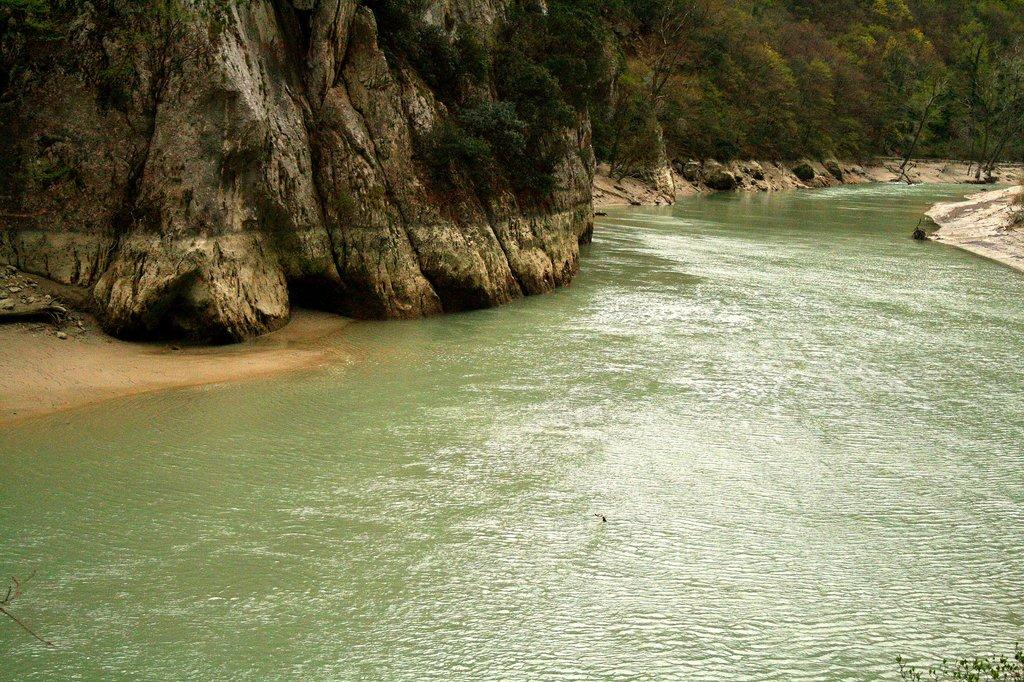What is visible in the image? Water is visible in the image. What can be seen in the background of the image? There are mountains and trees in the background of the image. How much money is being exchanged in the image? There is no money visible in the image; it features water, mountains, and trees. What type of rice is being harvested in the image? There is no rice or harvesting activity present in the image. 